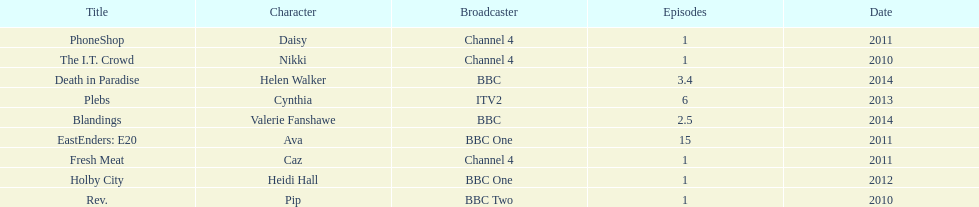What was the previous role this actress played before playing cynthia in plebs? Heidi Hall. 